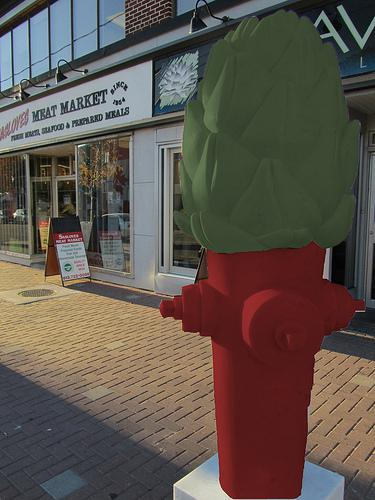Question: when was the photo taken?
Choices:
A. Midnight.
B. Daytime.
C. Just before sunrise.
D. Just after sunset.
Answer with the letter. Answer: B Question: what type of market is displayed?
Choices:
A. Persian rug market.
B. Supermarket.
C. Vegan craft market.
D. Meat market.
Answer with the letter. Answer: D Question: what color is bottom of hydrant?
Choices:
A. White.
B. Red.
C. Blue.
D. Orange.
Answer with the letter. Answer: A Question: what item is almost fully red?
Choices:
A. Fence.
B. Car.
C. Fire hydrant.
D. Motorcycle.
Answer with the letter. Answer: C Question: where is the sign?
Choices:
A. Behind the meat market.
B. To the left of the meat market.
C. To the right of the meat market.
D. Front of meat market.
Answer with the letter. Answer: D 